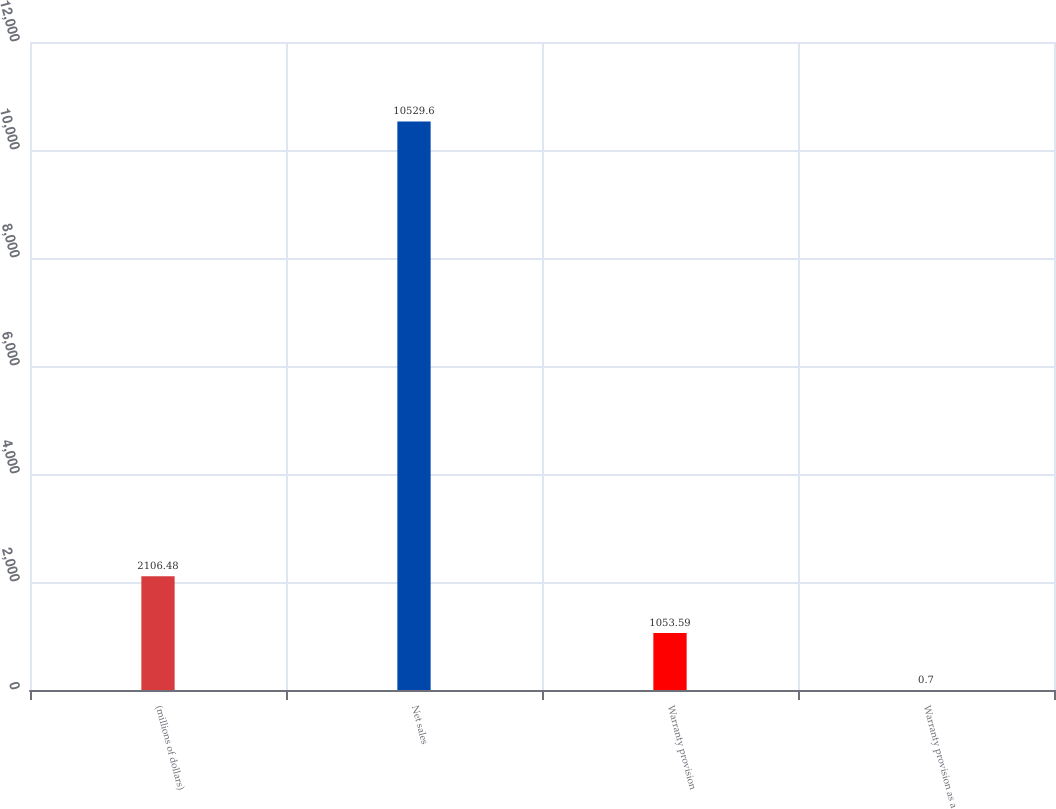<chart> <loc_0><loc_0><loc_500><loc_500><bar_chart><fcel>(millions of dollars)<fcel>Net sales<fcel>Warranty provision<fcel>Warranty provision as a<nl><fcel>2106.48<fcel>10529.6<fcel>1053.59<fcel>0.7<nl></chart> 